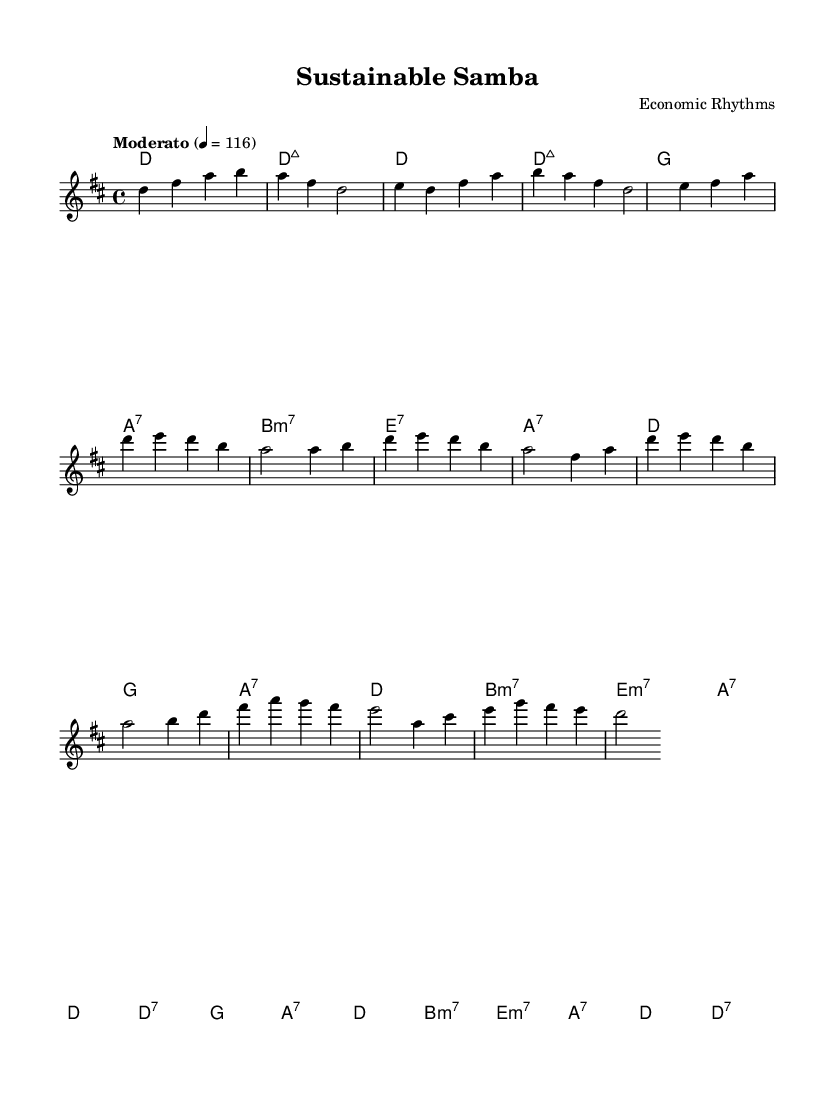What is the key signature of this music? The key signature is D major, which has two sharps: F# and C#. This can be identified by looking at the beginning of the sheet music where the key signature is indicated.
Answer: D major What is the time signature of this music? The time signature is 4/4, as indicated at the beginning of the score. This means there are four beats per measure, and the quarter note gets one beat.
Answer: 4/4 What is the tempo marking of this piece? The tempo marking is "Moderato," which indicates a moderate speed. In this score, it is specified as 4 = 116, meaning there are 116 beats per minute.
Answer: Moderato How many measures are in the chorus section? The chorus section consists of 8 measures, as can be determined by counting the measures in the specified chorus part of the sheet music.
Answer: 8 Which chord is used at the beginning of the verse section? The chord used at the beginning of the verse is D major 7. This can be identified at the start of the verse block beneath the melody line.
Answer: D:maj7 What type of harmony is predominant in Bossa Nova styles as seen in the provided sheet music? The harmony predominantly showcases seventh chords, typical of Bossa Nova's jazzy feel, which can be seen throughout the chord progressions in both the verse and chorus.
Answer: Seventh chords What is the last note of the melody? The last note of the melody is D. This can be confirmed by looking at the final measure of the melody line where it concludes.
Answer: D 